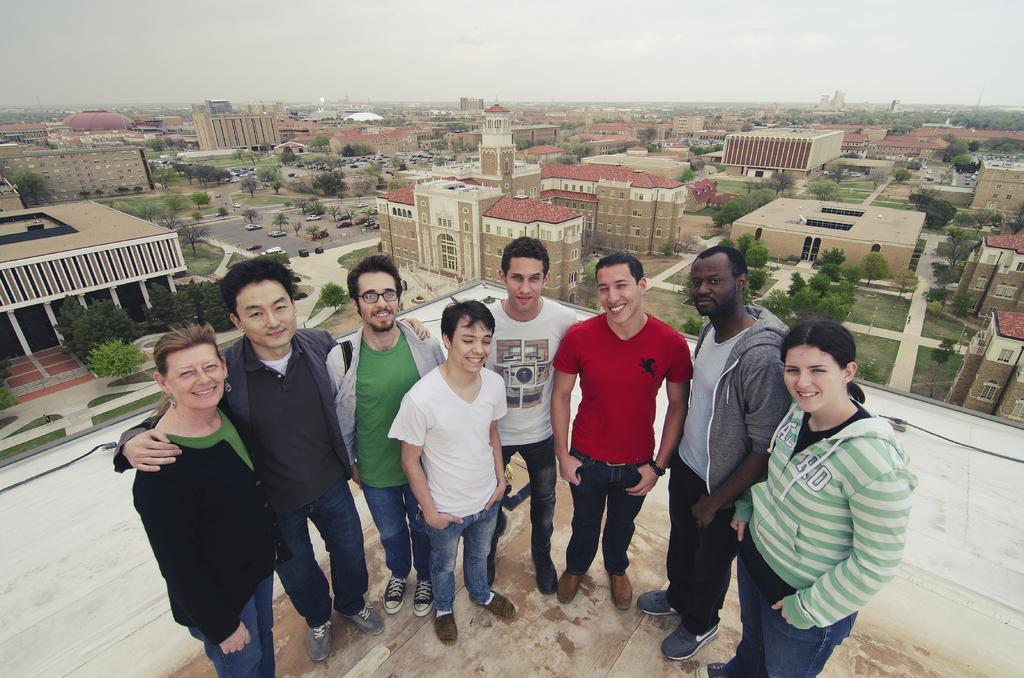What type of natural elements can be seen in the image? There are trees in the image. What type of man-made structures are visible in the image? There are buildings in the image. What are the people in the image doing? The people are standing in the middle of the image. What are the people wearing? The people are wearing clothes. What is visible at the top of the image? The sky is visible at the top of the image. What type of clam is being used as a fuel source in the image? There is no clam or fuel source present in the image. What type of fruit is being held by the people in the image? There is no fruit visible in the image; the people are not holding any fruit. 